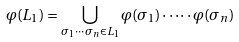Convert formula to latex. <formula><loc_0><loc_0><loc_500><loc_500>\varphi ( L _ { 1 } ) = \bigcup _ { \sigma _ { 1 } \cdots \sigma _ { n } \in L _ { 1 } } \varphi ( \sigma _ { 1 } ) \cdot \dots \cdot \varphi ( \sigma _ { n } )</formula> 